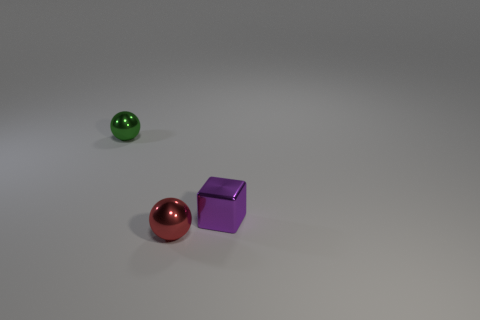Add 2 small balls. How many objects exist? 5 Subtract all balls. How many objects are left? 1 Subtract all large cyan metal cylinders. Subtract all small purple cubes. How many objects are left? 2 Add 2 tiny purple cubes. How many tiny purple cubes are left? 3 Add 1 small purple cubes. How many small purple cubes exist? 2 Subtract 0 blue cylinders. How many objects are left? 3 